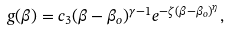<formula> <loc_0><loc_0><loc_500><loc_500>g ( \beta ) = c _ { 3 } ( \beta - \beta _ { o } ) ^ { \gamma - 1 } e ^ { - \zeta ( \beta - \beta _ { o } ) ^ { \eta } } ,</formula> 